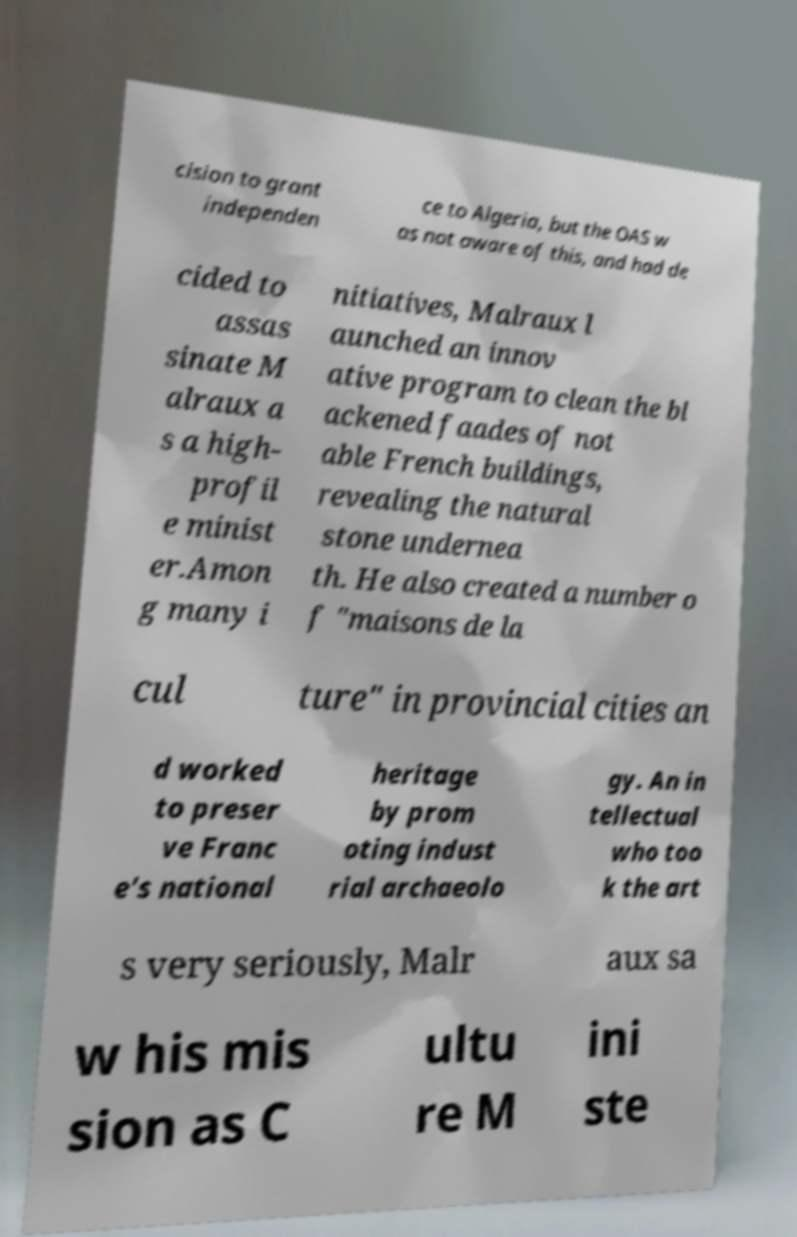Can you read and provide the text displayed in the image?This photo seems to have some interesting text. Can you extract and type it out for me? cision to grant independen ce to Algeria, but the OAS w as not aware of this, and had de cided to assas sinate M alraux a s a high- profil e minist er.Amon g many i nitiatives, Malraux l aunched an innov ative program to clean the bl ackened faades of not able French buildings, revealing the natural stone undernea th. He also created a number o f "maisons de la cul ture" in provincial cities an d worked to preser ve Franc e's national heritage by prom oting indust rial archaeolo gy. An in tellectual who too k the art s very seriously, Malr aux sa w his mis sion as C ultu re M ini ste 